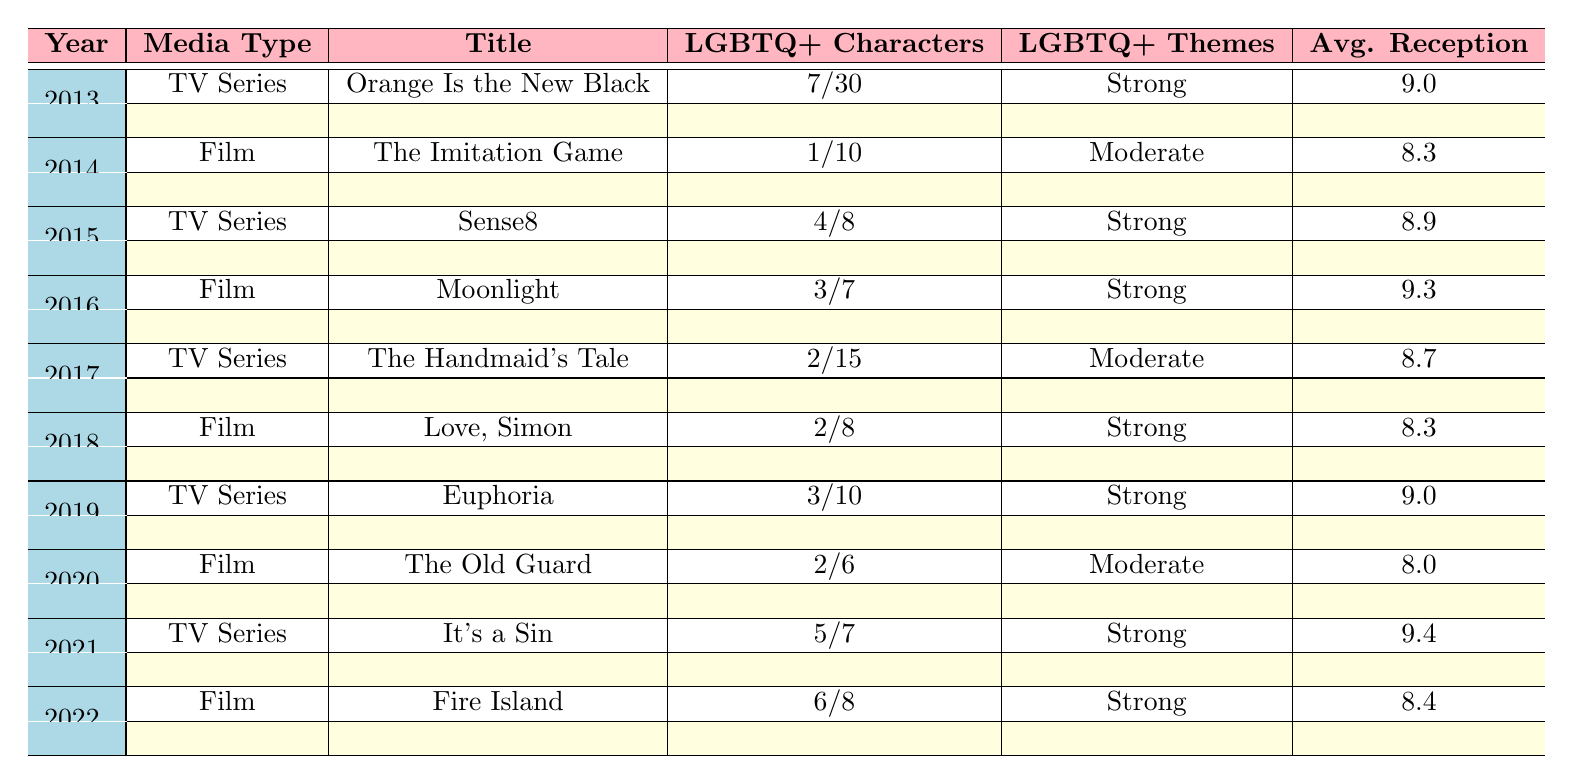What is the highest number of LGBTQ+ characters in a TV series from the table? The TV series "Orange Is the New Black" from 2013 has 7 LGBTQ+ characters, which is the highest count listed for any TV series in the table.
Answer: 7 In which year was the film "Moonlight" released, and how many LGBTQ+ characters does it have? "Moonlight" is a film from 2016 and has 3 LGBTQ+ characters, as indicated in the table under the year 2016.
Answer: 2016, 3 What is the average critical reception rating of films listed in the table? The critical reception ratings for films are: 8.5, 9.6, 7.9, 7.8, 8.1. Adding these gives 41.9. There are 5 films, so the average is 41.9/5 = 8.38.
Answer: 8.38 Which media type had more 'Strong' LGBTQ+ themes, TV series or films? The table shows "Strong" themes for TV series in 2013, 2015, 2016, 2019, 2021, and 2022, totaling 5 occurrences. For films, "Strong" themes appeared for 2016, 2018, and 2022, totaling 4 occurrences. Therefore, TV series had more.
Answer: TV series Did any film have fewer than 2 LGBTQ+ characters in the table? The film "The Imitation Game" from 2014 had only 1 LGBTQ+ character. This confirms that it is true that a film had fewer than 2 LGBTQ+ characters.
Answer: Yes What year saw the highest average reception for a TV series? The TV series "It's a Sin" from 2021 has the highest average reception of 9.4, which is higher than all other series' ratings listed.
Answer: 2021 How many total LGBTQ+ characters are there across all films listed in the table? Counting the LGBTQ+ characters in films: 1 (The Imitation Game) + 3 (Moonlight) + 2 (Love, Simon) + 2 (The Old Guard) + 6 (Fire Island) = 14 total LGBTQ+ characters across films.
Answer: 14 What was the audience's reception for "Euphoria"? The audience reception for "Euphoria," a TV series from 2019, is scored at 9.1, as per the data provided in the table.
Answer: 9.1 Which film and TV series had the same number of LGBTQ+ characters, and what was that number? The film "The Old Guard" (2020) and the TV series "Euphoria" (2019) both have 2 LGBTQ+ characters, making them the same.
Answer: 2 